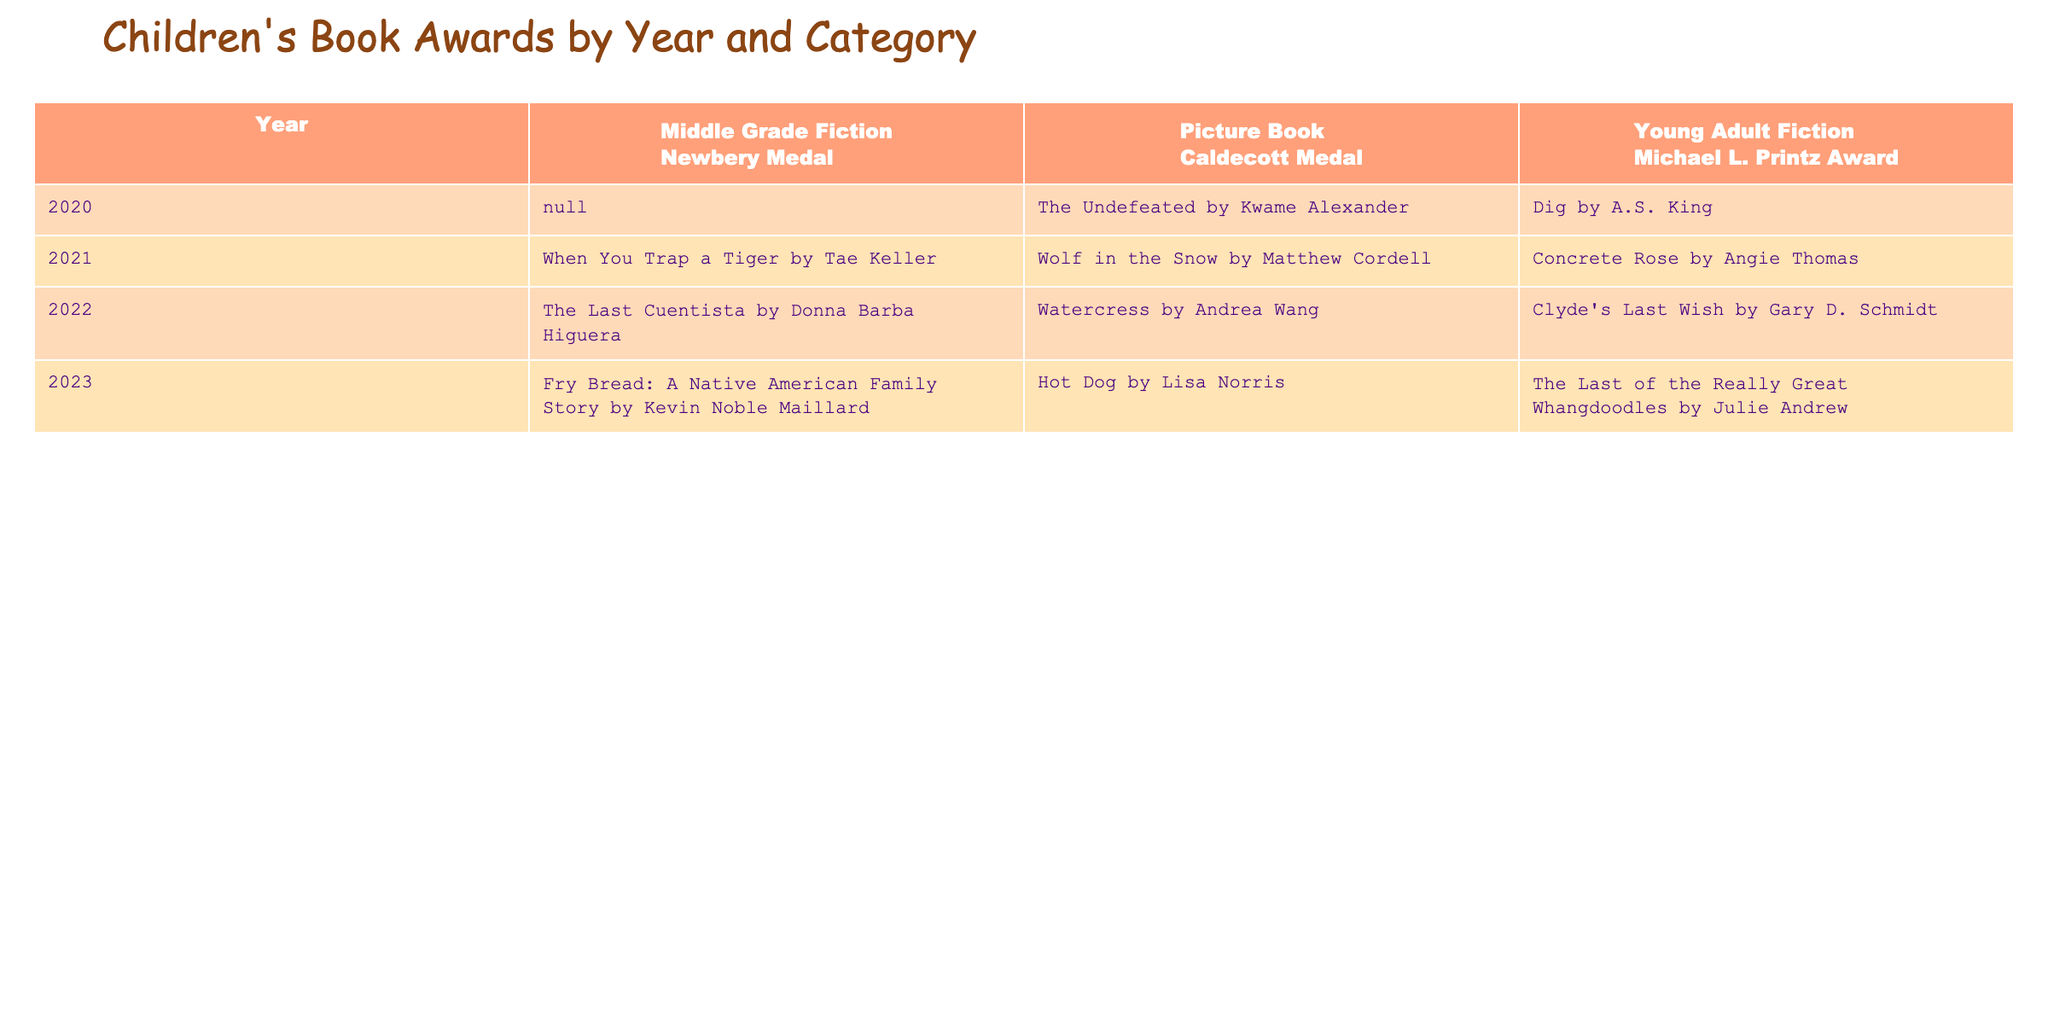What book won the Caldecott Medal in 2021? The table indicates that in 2021, the book "Wolf in the Snow" by Matthew Cordell won the Caldecott Medal under the Picture Book category.
Answer: Wolf in the Snow by Matthew Cordell Which category received the most awards from 2020 to 2023? By examining the table, it's observed that the Picture Book category consistently won the Caldecott Medal every year from 2020 to 2023, totaling four awards. The other categories have fewer recognitions in that time frame.
Answer: Picture Book In which year did the Newbery Medal not get awarded? Looking at the data, there wasn't any entry for the Newbery Medal in 2020, indicating that the Medal was not awarded that year.
Answer: 2020 Which is the winner of the Michael L. Printz Award for Young Adult Fiction in 2023? According to the table, "The Last of the Really Great Whangdoodles" by Julie Andrew won the Michael L. Printz Award for Young Adult Fiction in 2023.
Answer: The Last of the Really Great Whangdoodles by Julie Andrew How many different winners were there for the Newbery Medal from 2021 to 2023? From the table, the winners for the Newbery Medal over the specified years are "When You Trap a Tiger" in 2021, "The Last Cuentista" in 2022, and "Fry Bread: A Native American Family Story" in 2023. This totals three distinct winners in that period.
Answer: 3 Did any book win the Caldecott Medal in 2022? Yes, the table clearly shows that the book "Watercress" by Andrea Wang won the Caldecott Medal in 2022, confirming that a book indeed won that year.
Answer: Yes What was the trend of winners for the Michael L. Printz Award from 2020 to 2023? The table reveals that from 2020 to 2023, the Young Adult Fiction winners were "Dig" in 2020, "Concrete Rose" in 2021, "Clyde's Last Wish" in 2022, and "The Last of the Really Great Whangdoodles" in 2023. This shows a consistent recognition each year without any gaps.
Answer: Consistent recognition Which year experienced the highest diversity in award categories? Examining the data, the year 2021 had winners across all three categories: Picture Book, Middle Grade Fiction, and Young Adult Fiction, indicating higher diversity compared to other years.
Answer: 2021 